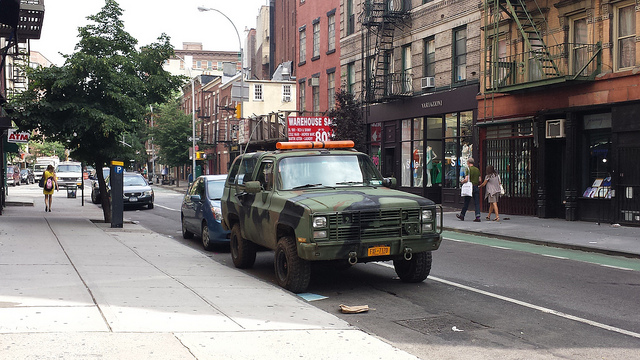Please transcribe the text in this image. ATM 